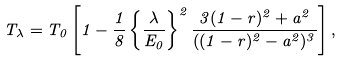Convert formula to latex. <formula><loc_0><loc_0><loc_500><loc_500>T _ { \lambda } = T _ { 0 } \left [ 1 - \frac { 1 } { 8 } \left \{ \frac { \lambda } { E _ { 0 } } \right \} ^ { 2 } \frac { 3 ( 1 - r ) ^ { 2 } + a ^ { 2 } } { ( ( 1 - r ) ^ { 2 } - a ^ { 2 } ) ^ { 3 } } \right ] ,</formula> 